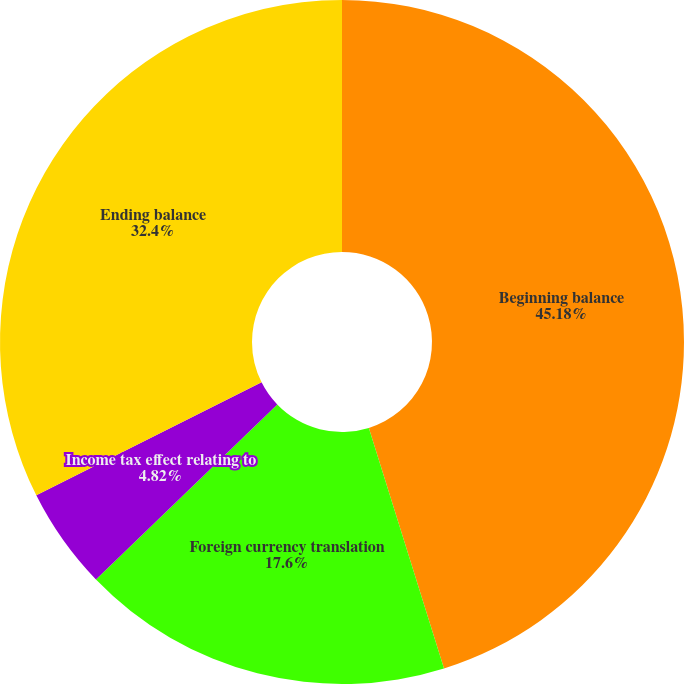Convert chart to OTSL. <chart><loc_0><loc_0><loc_500><loc_500><pie_chart><fcel>Beginning balance<fcel>Foreign currency translation<fcel>Income tax effect relating to<fcel>Ending balance<nl><fcel>45.18%<fcel>17.6%<fcel>4.82%<fcel>32.4%<nl></chart> 